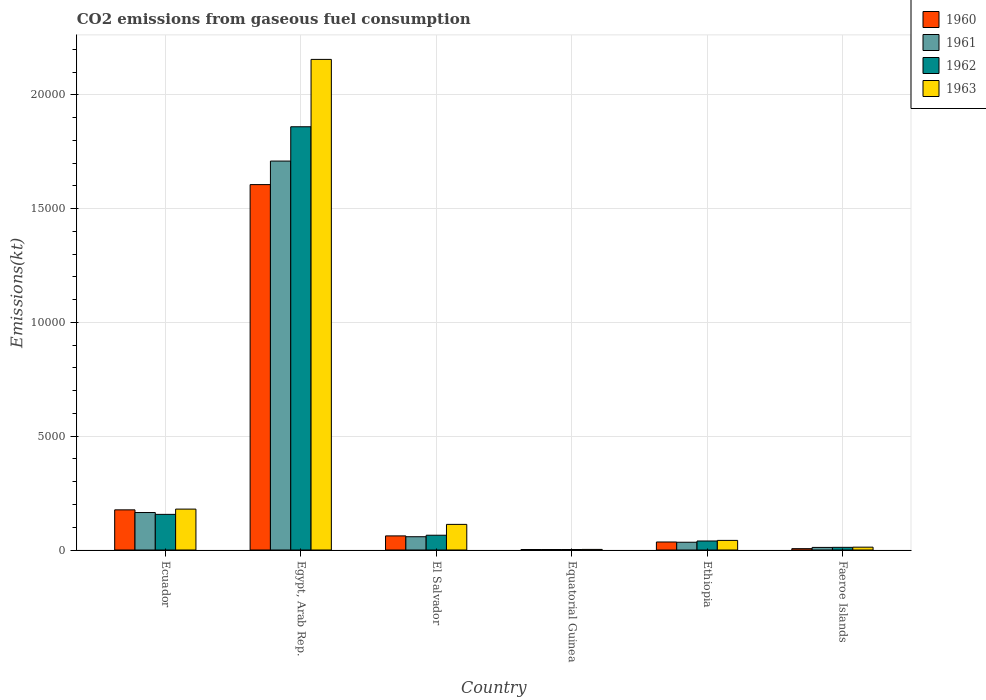How many groups of bars are there?
Your response must be concise. 6. How many bars are there on the 4th tick from the left?
Your answer should be very brief. 4. What is the label of the 4th group of bars from the left?
Make the answer very short. Equatorial Guinea. In how many cases, is the number of bars for a given country not equal to the number of legend labels?
Your answer should be very brief. 0. What is the amount of CO2 emitted in 1960 in Equatorial Guinea?
Ensure brevity in your answer.  22. Across all countries, what is the maximum amount of CO2 emitted in 1960?
Your response must be concise. 1.61e+04. Across all countries, what is the minimum amount of CO2 emitted in 1960?
Offer a very short reply. 22. In which country was the amount of CO2 emitted in 1962 maximum?
Give a very brief answer. Egypt, Arab Rep. In which country was the amount of CO2 emitted in 1963 minimum?
Keep it short and to the point. Equatorial Guinea. What is the total amount of CO2 emitted in 1961 in the graph?
Give a very brief answer. 1.98e+04. What is the difference between the amount of CO2 emitted in 1960 in Ecuador and that in Faeroe Islands?
Your response must be concise. 1705.15. What is the difference between the amount of CO2 emitted in 1962 in Equatorial Guinea and the amount of CO2 emitted in 1963 in Ecuador?
Your answer should be compact. -1774.83. What is the average amount of CO2 emitted in 1962 per country?
Your answer should be very brief. 3557.6. What is the difference between the amount of CO2 emitted of/in 1962 and amount of CO2 emitted of/in 1963 in Ecuador?
Your response must be concise. -231.02. What is the ratio of the amount of CO2 emitted in 1962 in El Salvador to that in Faeroe Islands?
Provide a succinct answer. 5.53. Is the difference between the amount of CO2 emitted in 1962 in Ecuador and El Salvador greater than the difference between the amount of CO2 emitted in 1963 in Ecuador and El Salvador?
Provide a succinct answer. Yes. What is the difference between the highest and the second highest amount of CO2 emitted in 1962?
Provide a short and direct response. -1.79e+04. What is the difference between the highest and the lowest amount of CO2 emitted in 1961?
Give a very brief answer. 1.71e+04. In how many countries, is the amount of CO2 emitted in 1963 greater than the average amount of CO2 emitted in 1963 taken over all countries?
Provide a succinct answer. 1. What does the 1st bar from the right in Faeroe Islands represents?
Your response must be concise. 1963. How many bars are there?
Your answer should be compact. 24. Are all the bars in the graph horizontal?
Your answer should be compact. No. How many countries are there in the graph?
Provide a short and direct response. 6. Are the values on the major ticks of Y-axis written in scientific E-notation?
Ensure brevity in your answer.  No. Does the graph contain any zero values?
Give a very brief answer. No. Where does the legend appear in the graph?
Keep it short and to the point. Top right. How many legend labels are there?
Provide a succinct answer. 4. How are the legend labels stacked?
Your answer should be compact. Vertical. What is the title of the graph?
Your response must be concise. CO2 emissions from gaseous fuel consumption. What is the label or title of the X-axis?
Offer a terse response. Country. What is the label or title of the Y-axis?
Your response must be concise. Emissions(kt). What is the Emissions(kt) in 1960 in Ecuador?
Your answer should be very brief. 1763.83. What is the Emissions(kt) in 1961 in Ecuador?
Give a very brief answer. 1646.48. What is the Emissions(kt) in 1962 in Ecuador?
Your answer should be compact. 1565.81. What is the Emissions(kt) of 1963 in Ecuador?
Offer a very short reply. 1796.83. What is the Emissions(kt) in 1960 in Egypt, Arab Rep.?
Your response must be concise. 1.61e+04. What is the Emissions(kt) of 1961 in Egypt, Arab Rep.?
Your answer should be very brief. 1.71e+04. What is the Emissions(kt) of 1962 in Egypt, Arab Rep.?
Offer a terse response. 1.86e+04. What is the Emissions(kt) in 1963 in Egypt, Arab Rep.?
Your answer should be very brief. 2.16e+04. What is the Emissions(kt) in 1960 in El Salvador?
Your answer should be compact. 619.72. What is the Emissions(kt) of 1961 in El Salvador?
Provide a succinct answer. 583.05. What is the Emissions(kt) in 1962 in El Salvador?
Give a very brief answer. 649.06. What is the Emissions(kt) of 1963 in El Salvador?
Your response must be concise. 1125.77. What is the Emissions(kt) in 1960 in Equatorial Guinea?
Give a very brief answer. 22. What is the Emissions(kt) of 1961 in Equatorial Guinea?
Provide a short and direct response. 22. What is the Emissions(kt) in 1962 in Equatorial Guinea?
Give a very brief answer. 22. What is the Emissions(kt) in 1963 in Equatorial Guinea?
Give a very brief answer. 25.67. What is the Emissions(kt) in 1960 in Ethiopia?
Keep it short and to the point. 352.03. What is the Emissions(kt) in 1961 in Ethiopia?
Offer a terse response. 341.03. What is the Emissions(kt) in 1962 in Ethiopia?
Your answer should be very brief. 396.04. What is the Emissions(kt) in 1963 in Ethiopia?
Offer a terse response. 421.7. What is the Emissions(kt) in 1960 in Faeroe Islands?
Give a very brief answer. 58.67. What is the Emissions(kt) of 1961 in Faeroe Islands?
Give a very brief answer. 113.68. What is the Emissions(kt) in 1962 in Faeroe Islands?
Ensure brevity in your answer.  117.34. What is the Emissions(kt) of 1963 in Faeroe Islands?
Your answer should be very brief. 124.68. Across all countries, what is the maximum Emissions(kt) of 1960?
Provide a short and direct response. 1.61e+04. Across all countries, what is the maximum Emissions(kt) in 1961?
Your answer should be compact. 1.71e+04. Across all countries, what is the maximum Emissions(kt) in 1962?
Provide a succinct answer. 1.86e+04. Across all countries, what is the maximum Emissions(kt) in 1963?
Your answer should be very brief. 2.16e+04. Across all countries, what is the minimum Emissions(kt) of 1960?
Ensure brevity in your answer.  22. Across all countries, what is the minimum Emissions(kt) of 1961?
Ensure brevity in your answer.  22. Across all countries, what is the minimum Emissions(kt) of 1962?
Your answer should be compact. 22. Across all countries, what is the minimum Emissions(kt) of 1963?
Your answer should be very brief. 25.67. What is the total Emissions(kt) in 1960 in the graph?
Your answer should be very brief. 1.89e+04. What is the total Emissions(kt) in 1961 in the graph?
Make the answer very short. 1.98e+04. What is the total Emissions(kt) of 1962 in the graph?
Provide a succinct answer. 2.13e+04. What is the total Emissions(kt) in 1963 in the graph?
Your answer should be compact. 2.50e+04. What is the difference between the Emissions(kt) in 1960 in Ecuador and that in Egypt, Arab Rep.?
Your response must be concise. -1.43e+04. What is the difference between the Emissions(kt) in 1961 in Ecuador and that in Egypt, Arab Rep.?
Your answer should be compact. -1.54e+04. What is the difference between the Emissions(kt) of 1962 in Ecuador and that in Egypt, Arab Rep.?
Ensure brevity in your answer.  -1.70e+04. What is the difference between the Emissions(kt) of 1963 in Ecuador and that in Egypt, Arab Rep.?
Offer a very short reply. -1.98e+04. What is the difference between the Emissions(kt) in 1960 in Ecuador and that in El Salvador?
Offer a very short reply. 1144.1. What is the difference between the Emissions(kt) in 1961 in Ecuador and that in El Salvador?
Ensure brevity in your answer.  1063.43. What is the difference between the Emissions(kt) in 1962 in Ecuador and that in El Salvador?
Provide a succinct answer. 916.75. What is the difference between the Emissions(kt) in 1963 in Ecuador and that in El Salvador?
Keep it short and to the point. 671.06. What is the difference between the Emissions(kt) in 1960 in Ecuador and that in Equatorial Guinea?
Give a very brief answer. 1741.83. What is the difference between the Emissions(kt) in 1961 in Ecuador and that in Equatorial Guinea?
Your response must be concise. 1624.48. What is the difference between the Emissions(kt) of 1962 in Ecuador and that in Equatorial Guinea?
Give a very brief answer. 1543.81. What is the difference between the Emissions(kt) of 1963 in Ecuador and that in Equatorial Guinea?
Ensure brevity in your answer.  1771.16. What is the difference between the Emissions(kt) in 1960 in Ecuador and that in Ethiopia?
Provide a short and direct response. 1411.8. What is the difference between the Emissions(kt) of 1961 in Ecuador and that in Ethiopia?
Your answer should be very brief. 1305.45. What is the difference between the Emissions(kt) of 1962 in Ecuador and that in Ethiopia?
Give a very brief answer. 1169.77. What is the difference between the Emissions(kt) of 1963 in Ecuador and that in Ethiopia?
Give a very brief answer. 1375.12. What is the difference between the Emissions(kt) in 1960 in Ecuador and that in Faeroe Islands?
Your response must be concise. 1705.15. What is the difference between the Emissions(kt) in 1961 in Ecuador and that in Faeroe Islands?
Provide a short and direct response. 1532.81. What is the difference between the Emissions(kt) in 1962 in Ecuador and that in Faeroe Islands?
Provide a short and direct response. 1448.46. What is the difference between the Emissions(kt) of 1963 in Ecuador and that in Faeroe Islands?
Offer a very short reply. 1672.15. What is the difference between the Emissions(kt) in 1960 in Egypt, Arab Rep. and that in El Salvador?
Your response must be concise. 1.54e+04. What is the difference between the Emissions(kt) of 1961 in Egypt, Arab Rep. and that in El Salvador?
Your response must be concise. 1.65e+04. What is the difference between the Emissions(kt) in 1962 in Egypt, Arab Rep. and that in El Salvador?
Keep it short and to the point. 1.79e+04. What is the difference between the Emissions(kt) in 1963 in Egypt, Arab Rep. and that in El Salvador?
Your answer should be compact. 2.04e+04. What is the difference between the Emissions(kt) of 1960 in Egypt, Arab Rep. and that in Equatorial Guinea?
Provide a succinct answer. 1.60e+04. What is the difference between the Emissions(kt) in 1961 in Egypt, Arab Rep. and that in Equatorial Guinea?
Provide a short and direct response. 1.71e+04. What is the difference between the Emissions(kt) in 1962 in Egypt, Arab Rep. and that in Equatorial Guinea?
Provide a short and direct response. 1.86e+04. What is the difference between the Emissions(kt) in 1963 in Egypt, Arab Rep. and that in Equatorial Guinea?
Provide a short and direct response. 2.15e+04. What is the difference between the Emissions(kt) of 1960 in Egypt, Arab Rep. and that in Ethiopia?
Give a very brief answer. 1.57e+04. What is the difference between the Emissions(kt) of 1961 in Egypt, Arab Rep. and that in Ethiopia?
Offer a terse response. 1.67e+04. What is the difference between the Emissions(kt) of 1962 in Egypt, Arab Rep. and that in Ethiopia?
Make the answer very short. 1.82e+04. What is the difference between the Emissions(kt) in 1963 in Egypt, Arab Rep. and that in Ethiopia?
Make the answer very short. 2.11e+04. What is the difference between the Emissions(kt) in 1960 in Egypt, Arab Rep. and that in Faeroe Islands?
Ensure brevity in your answer.  1.60e+04. What is the difference between the Emissions(kt) of 1961 in Egypt, Arab Rep. and that in Faeroe Islands?
Your response must be concise. 1.70e+04. What is the difference between the Emissions(kt) of 1962 in Egypt, Arab Rep. and that in Faeroe Islands?
Keep it short and to the point. 1.85e+04. What is the difference between the Emissions(kt) of 1963 in Egypt, Arab Rep. and that in Faeroe Islands?
Keep it short and to the point. 2.14e+04. What is the difference between the Emissions(kt) of 1960 in El Salvador and that in Equatorial Guinea?
Provide a short and direct response. 597.72. What is the difference between the Emissions(kt) in 1961 in El Salvador and that in Equatorial Guinea?
Make the answer very short. 561.05. What is the difference between the Emissions(kt) of 1962 in El Salvador and that in Equatorial Guinea?
Ensure brevity in your answer.  627.06. What is the difference between the Emissions(kt) in 1963 in El Salvador and that in Equatorial Guinea?
Your answer should be compact. 1100.1. What is the difference between the Emissions(kt) of 1960 in El Salvador and that in Ethiopia?
Make the answer very short. 267.69. What is the difference between the Emissions(kt) in 1961 in El Salvador and that in Ethiopia?
Offer a very short reply. 242.02. What is the difference between the Emissions(kt) in 1962 in El Salvador and that in Ethiopia?
Your answer should be compact. 253.02. What is the difference between the Emissions(kt) of 1963 in El Salvador and that in Ethiopia?
Provide a short and direct response. 704.06. What is the difference between the Emissions(kt) of 1960 in El Salvador and that in Faeroe Islands?
Make the answer very short. 561.05. What is the difference between the Emissions(kt) in 1961 in El Salvador and that in Faeroe Islands?
Ensure brevity in your answer.  469.38. What is the difference between the Emissions(kt) of 1962 in El Salvador and that in Faeroe Islands?
Your response must be concise. 531.72. What is the difference between the Emissions(kt) in 1963 in El Salvador and that in Faeroe Islands?
Make the answer very short. 1001.09. What is the difference between the Emissions(kt) of 1960 in Equatorial Guinea and that in Ethiopia?
Offer a very short reply. -330.03. What is the difference between the Emissions(kt) in 1961 in Equatorial Guinea and that in Ethiopia?
Make the answer very short. -319.03. What is the difference between the Emissions(kt) in 1962 in Equatorial Guinea and that in Ethiopia?
Provide a succinct answer. -374.03. What is the difference between the Emissions(kt) of 1963 in Equatorial Guinea and that in Ethiopia?
Offer a very short reply. -396.04. What is the difference between the Emissions(kt) in 1960 in Equatorial Guinea and that in Faeroe Islands?
Your answer should be very brief. -36.67. What is the difference between the Emissions(kt) of 1961 in Equatorial Guinea and that in Faeroe Islands?
Offer a very short reply. -91.67. What is the difference between the Emissions(kt) in 1962 in Equatorial Guinea and that in Faeroe Islands?
Your answer should be compact. -95.34. What is the difference between the Emissions(kt) of 1963 in Equatorial Guinea and that in Faeroe Islands?
Your response must be concise. -99.01. What is the difference between the Emissions(kt) of 1960 in Ethiopia and that in Faeroe Islands?
Your response must be concise. 293.36. What is the difference between the Emissions(kt) of 1961 in Ethiopia and that in Faeroe Islands?
Offer a very short reply. 227.35. What is the difference between the Emissions(kt) in 1962 in Ethiopia and that in Faeroe Islands?
Offer a terse response. 278.69. What is the difference between the Emissions(kt) in 1963 in Ethiopia and that in Faeroe Islands?
Your answer should be compact. 297.03. What is the difference between the Emissions(kt) in 1960 in Ecuador and the Emissions(kt) in 1961 in Egypt, Arab Rep.?
Give a very brief answer. -1.53e+04. What is the difference between the Emissions(kt) of 1960 in Ecuador and the Emissions(kt) of 1962 in Egypt, Arab Rep.?
Provide a succinct answer. -1.68e+04. What is the difference between the Emissions(kt) in 1960 in Ecuador and the Emissions(kt) in 1963 in Egypt, Arab Rep.?
Offer a very short reply. -1.98e+04. What is the difference between the Emissions(kt) in 1961 in Ecuador and the Emissions(kt) in 1962 in Egypt, Arab Rep.?
Ensure brevity in your answer.  -1.69e+04. What is the difference between the Emissions(kt) of 1961 in Ecuador and the Emissions(kt) of 1963 in Egypt, Arab Rep.?
Ensure brevity in your answer.  -1.99e+04. What is the difference between the Emissions(kt) of 1962 in Ecuador and the Emissions(kt) of 1963 in Egypt, Arab Rep.?
Offer a very short reply. -2.00e+04. What is the difference between the Emissions(kt) in 1960 in Ecuador and the Emissions(kt) in 1961 in El Salvador?
Make the answer very short. 1180.77. What is the difference between the Emissions(kt) of 1960 in Ecuador and the Emissions(kt) of 1962 in El Salvador?
Provide a succinct answer. 1114.77. What is the difference between the Emissions(kt) of 1960 in Ecuador and the Emissions(kt) of 1963 in El Salvador?
Your answer should be compact. 638.06. What is the difference between the Emissions(kt) of 1961 in Ecuador and the Emissions(kt) of 1962 in El Salvador?
Offer a very short reply. 997.42. What is the difference between the Emissions(kt) of 1961 in Ecuador and the Emissions(kt) of 1963 in El Salvador?
Provide a succinct answer. 520.71. What is the difference between the Emissions(kt) in 1962 in Ecuador and the Emissions(kt) in 1963 in El Salvador?
Offer a terse response. 440.04. What is the difference between the Emissions(kt) in 1960 in Ecuador and the Emissions(kt) in 1961 in Equatorial Guinea?
Provide a succinct answer. 1741.83. What is the difference between the Emissions(kt) in 1960 in Ecuador and the Emissions(kt) in 1962 in Equatorial Guinea?
Ensure brevity in your answer.  1741.83. What is the difference between the Emissions(kt) in 1960 in Ecuador and the Emissions(kt) in 1963 in Equatorial Guinea?
Keep it short and to the point. 1738.16. What is the difference between the Emissions(kt) of 1961 in Ecuador and the Emissions(kt) of 1962 in Equatorial Guinea?
Offer a very short reply. 1624.48. What is the difference between the Emissions(kt) in 1961 in Ecuador and the Emissions(kt) in 1963 in Equatorial Guinea?
Your answer should be very brief. 1620.81. What is the difference between the Emissions(kt) in 1962 in Ecuador and the Emissions(kt) in 1963 in Equatorial Guinea?
Offer a very short reply. 1540.14. What is the difference between the Emissions(kt) of 1960 in Ecuador and the Emissions(kt) of 1961 in Ethiopia?
Your answer should be very brief. 1422.8. What is the difference between the Emissions(kt) in 1960 in Ecuador and the Emissions(kt) in 1962 in Ethiopia?
Ensure brevity in your answer.  1367.79. What is the difference between the Emissions(kt) in 1960 in Ecuador and the Emissions(kt) in 1963 in Ethiopia?
Offer a very short reply. 1342.12. What is the difference between the Emissions(kt) of 1961 in Ecuador and the Emissions(kt) of 1962 in Ethiopia?
Ensure brevity in your answer.  1250.45. What is the difference between the Emissions(kt) of 1961 in Ecuador and the Emissions(kt) of 1963 in Ethiopia?
Offer a very short reply. 1224.78. What is the difference between the Emissions(kt) of 1962 in Ecuador and the Emissions(kt) of 1963 in Ethiopia?
Offer a terse response. 1144.1. What is the difference between the Emissions(kt) of 1960 in Ecuador and the Emissions(kt) of 1961 in Faeroe Islands?
Give a very brief answer. 1650.15. What is the difference between the Emissions(kt) in 1960 in Ecuador and the Emissions(kt) in 1962 in Faeroe Islands?
Provide a succinct answer. 1646.48. What is the difference between the Emissions(kt) of 1960 in Ecuador and the Emissions(kt) of 1963 in Faeroe Islands?
Provide a succinct answer. 1639.15. What is the difference between the Emissions(kt) in 1961 in Ecuador and the Emissions(kt) in 1962 in Faeroe Islands?
Your response must be concise. 1529.14. What is the difference between the Emissions(kt) of 1961 in Ecuador and the Emissions(kt) of 1963 in Faeroe Islands?
Make the answer very short. 1521.81. What is the difference between the Emissions(kt) in 1962 in Ecuador and the Emissions(kt) in 1963 in Faeroe Islands?
Your answer should be very brief. 1441.13. What is the difference between the Emissions(kt) in 1960 in Egypt, Arab Rep. and the Emissions(kt) in 1961 in El Salvador?
Provide a short and direct response. 1.55e+04. What is the difference between the Emissions(kt) of 1960 in Egypt, Arab Rep. and the Emissions(kt) of 1962 in El Salvador?
Provide a short and direct response. 1.54e+04. What is the difference between the Emissions(kt) of 1960 in Egypt, Arab Rep. and the Emissions(kt) of 1963 in El Salvador?
Your response must be concise. 1.49e+04. What is the difference between the Emissions(kt) of 1961 in Egypt, Arab Rep. and the Emissions(kt) of 1962 in El Salvador?
Ensure brevity in your answer.  1.64e+04. What is the difference between the Emissions(kt) in 1961 in Egypt, Arab Rep. and the Emissions(kt) in 1963 in El Salvador?
Offer a very short reply. 1.60e+04. What is the difference between the Emissions(kt) in 1962 in Egypt, Arab Rep. and the Emissions(kt) in 1963 in El Salvador?
Give a very brief answer. 1.75e+04. What is the difference between the Emissions(kt) in 1960 in Egypt, Arab Rep. and the Emissions(kt) in 1961 in Equatorial Guinea?
Offer a very short reply. 1.60e+04. What is the difference between the Emissions(kt) of 1960 in Egypt, Arab Rep. and the Emissions(kt) of 1962 in Equatorial Guinea?
Ensure brevity in your answer.  1.60e+04. What is the difference between the Emissions(kt) of 1960 in Egypt, Arab Rep. and the Emissions(kt) of 1963 in Equatorial Guinea?
Give a very brief answer. 1.60e+04. What is the difference between the Emissions(kt) of 1961 in Egypt, Arab Rep. and the Emissions(kt) of 1962 in Equatorial Guinea?
Give a very brief answer. 1.71e+04. What is the difference between the Emissions(kt) of 1961 in Egypt, Arab Rep. and the Emissions(kt) of 1963 in Equatorial Guinea?
Make the answer very short. 1.71e+04. What is the difference between the Emissions(kt) in 1962 in Egypt, Arab Rep. and the Emissions(kt) in 1963 in Equatorial Guinea?
Provide a short and direct response. 1.86e+04. What is the difference between the Emissions(kt) in 1960 in Egypt, Arab Rep. and the Emissions(kt) in 1961 in Ethiopia?
Ensure brevity in your answer.  1.57e+04. What is the difference between the Emissions(kt) of 1960 in Egypt, Arab Rep. and the Emissions(kt) of 1962 in Ethiopia?
Your answer should be compact. 1.57e+04. What is the difference between the Emissions(kt) in 1960 in Egypt, Arab Rep. and the Emissions(kt) in 1963 in Ethiopia?
Provide a short and direct response. 1.56e+04. What is the difference between the Emissions(kt) of 1961 in Egypt, Arab Rep. and the Emissions(kt) of 1962 in Ethiopia?
Make the answer very short. 1.67e+04. What is the difference between the Emissions(kt) of 1961 in Egypt, Arab Rep. and the Emissions(kt) of 1963 in Ethiopia?
Provide a short and direct response. 1.67e+04. What is the difference between the Emissions(kt) in 1962 in Egypt, Arab Rep. and the Emissions(kt) in 1963 in Ethiopia?
Keep it short and to the point. 1.82e+04. What is the difference between the Emissions(kt) of 1960 in Egypt, Arab Rep. and the Emissions(kt) of 1961 in Faeroe Islands?
Provide a short and direct response. 1.59e+04. What is the difference between the Emissions(kt) in 1960 in Egypt, Arab Rep. and the Emissions(kt) in 1962 in Faeroe Islands?
Your answer should be compact. 1.59e+04. What is the difference between the Emissions(kt) in 1960 in Egypt, Arab Rep. and the Emissions(kt) in 1963 in Faeroe Islands?
Your answer should be compact. 1.59e+04. What is the difference between the Emissions(kt) in 1961 in Egypt, Arab Rep. and the Emissions(kt) in 1962 in Faeroe Islands?
Provide a short and direct response. 1.70e+04. What is the difference between the Emissions(kt) of 1961 in Egypt, Arab Rep. and the Emissions(kt) of 1963 in Faeroe Islands?
Ensure brevity in your answer.  1.70e+04. What is the difference between the Emissions(kt) of 1962 in Egypt, Arab Rep. and the Emissions(kt) of 1963 in Faeroe Islands?
Provide a succinct answer. 1.85e+04. What is the difference between the Emissions(kt) of 1960 in El Salvador and the Emissions(kt) of 1961 in Equatorial Guinea?
Your answer should be very brief. 597.72. What is the difference between the Emissions(kt) of 1960 in El Salvador and the Emissions(kt) of 1962 in Equatorial Guinea?
Offer a very short reply. 597.72. What is the difference between the Emissions(kt) of 1960 in El Salvador and the Emissions(kt) of 1963 in Equatorial Guinea?
Offer a terse response. 594.05. What is the difference between the Emissions(kt) in 1961 in El Salvador and the Emissions(kt) in 1962 in Equatorial Guinea?
Keep it short and to the point. 561.05. What is the difference between the Emissions(kt) in 1961 in El Salvador and the Emissions(kt) in 1963 in Equatorial Guinea?
Give a very brief answer. 557.38. What is the difference between the Emissions(kt) of 1962 in El Salvador and the Emissions(kt) of 1963 in Equatorial Guinea?
Offer a terse response. 623.39. What is the difference between the Emissions(kt) of 1960 in El Salvador and the Emissions(kt) of 1961 in Ethiopia?
Your answer should be compact. 278.69. What is the difference between the Emissions(kt) of 1960 in El Salvador and the Emissions(kt) of 1962 in Ethiopia?
Make the answer very short. 223.69. What is the difference between the Emissions(kt) in 1960 in El Salvador and the Emissions(kt) in 1963 in Ethiopia?
Offer a very short reply. 198.02. What is the difference between the Emissions(kt) in 1961 in El Salvador and the Emissions(kt) in 1962 in Ethiopia?
Your answer should be very brief. 187.02. What is the difference between the Emissions(kt) in 1961 in El Salvador and the Emissions(kt) in 1963 in Ethiopia?
Offer a terse response. 161.35. What is the difference between the Emissions(kt) of 1962 in El Salvador and the Emissions(kt) of 1963 in Ethiopia?
Your response must be concise. 227.35. What is the difference between the Emissions(kt) in 1960 in El Salvador and the Emissions(kt) in 1961 in Faeroe Islands?
Your answer should be compact. 506.05. What is the difference between the Emissions(kt) in 1960 in El Salvador and the Emissions(kt) in 1962 in Faeroe Islands?
Provide a short and direct response. 502.38. What is the difference between the Emissions(kt) of 1960 in El Salvador and the Emissions(kt) of 1963 in Faeroe Islands?
Offer a terse response. 495.05. What is the difference between the Emissions(kt) of 1961 in El Salvador and the Emissions(kt) of 1962 in Faeroe Islands?
Make the answer very short. 465.71. What is the difference between the Emissions(kt) in 1961 in El Salvador and the Emissions(kt) in 1963 in Faeroe Islands?
Give a very brief answer. 458.38. What is the difference between the Emissions(kt) of 1962 in El Salvador and the Emissions(kt) of 1963 in Faeroe Islands?
Keep it short and to the point. 524.38. What is the difference between the Emissions(kt) of 1960 in Equatorial Guinea and the Emissions(kt) of 1961 in Ethiopia?
Offer a terse response. -319.03. What is the difference between the Emissions(kt) of 1960 in Equatorial Guinea and the Emissions(kt) of 1962 in Ethiopia?
Provide a succinct answer. -374.03. What is the difference between the Emissions(kt) in 1960 in Equatorial Guinea and the Emissions(kt) in 1963 in Ethiopia?
Provide a succinct answer. -399.7. What is the difference between the Emissions(kt) of 1961 in Equatorial Guinea and the Emissions(kt) of 1962 in Ethiopia?
Keep it short and to the point. -374.03. What is the difference between the Emissions(kt) in 1961 in Equatorial Guinea and the Emissions(kt) in 1963 in Ethiopia?
Keep it short and to the point. -399.7. What is the difference between the Emissions(kt) of 1962 in Equatorial Guinea and the Emissions(kt) of 1963 in Ethiopia?
Your answer should be compact. -399.7. What is the difference between the Emissions(kt) of 1960 in Equatorial Guinea and the Emissions(kt) of 1961 in Faeroe Islands?
Provide a succinct answer. -91.67. What is the difference between the Emissions(kt) of 1960 in Equatorial Guinea and the Emissions(kt) of 1962 in Faeroe Islands?
Keep it short and to the point. -95.34. What is the difference between the Emissions(kt) in 1960 in Equatorial Guinea and the Emissions(kt) in 1963 in Faeroe Islands?
Your response must be concise. -102.68. What is the difference between the Emissions(kt) of 1961 in Equatorial Guinea and the Emissions(kt) of 1962 in Faeroe Islands?
Ensure brevity in your answer.  -95.34. What is the difference between the Emissions(kt) in 1961 in Equatorial Guinea and the Emissions(kt) in 1963 in Faeroe Islands?
Your answer should be very brief. -102.68. What is the difference between the Emissions(kt) of 1962 in Equatorial Guinea and the Emissions(kt) of 1963 in Faeroe Islands?
Your answer should be very brief. -102.68. What is the difference between the Emissions(kt) in 1960 in Ethiopia and the Emissions(kt) in 1961 in Faeroe Islands?
Provide a succinct answer. 238.35. What is the difference between the Emissions(kt) in 1960 in Ethiopia and the Emissions(kt) in 1962 in Faeroe Islands?
Offer a very short reply. 234.69. What is the difference between the Emissions(kt) in 1960 in Ethiopia and the Emissions(kt) in 1963 in Faeroe Islands?
Your response must be concise. 227.35. What is the difference between the Emissions(kt) of 1961 in Ethiopia and the Emissions(kt) of 1962 in Faeroe Islands?
Offer a very short reply. 223.69. What is the difference between the Emissions(kt) in 1961 in Ethiopia and the Emissions(kt) in 1963 in Faeroe Islands?
Provide a succinct answer. 216.35. What is the difference between the Emissions(kt) of 1962 in Ethiopia and the Emissions(kt) of 1963 in Faeroe Islands?
Keep it short and to the point. 271.36. What is the average Emissions(kt) of 1960 per country?
Keep it short and to the point. 3145.06. What is the average Emissions(kt) in 1961 per country?
Offer a very short reply. 3299.08. What is the average Emissions(kt) of 1962 per country?
Offer a terse response. 3557.6. What is the average Emissions(kt) in 1963 per country?
Offer a terse response. 4174.88. What is the difference between the Emissions(kt) of 1960 and Emissions(kt) of 1961 in Ecuador?
Your answer should be very brief. 117.34. What is the difference between the Emissions(kt) of 1960 and Emissions(kt) of 1962 in Ecuador?
Make the answer very short. 198.02. What is the difference between the Emissions(kt) in 1960 and Emissions(kt) in 1963 in Ecuador?
Provide a succinct answer. -33. What is the difference between the Emissions(kt) in 1961 and Emissions(kt) in 1962 in Ecuador?
Provide a short and direct response. 80.67. What is the difference between the Emissions(kt) of 1961 and Emissions(kt) of 1963 in Ecuador?
Your answer should be compact. -150.35. What is the difference between the Emissions(kt) in 1962 and Emissions(kt) in 1963 in Ecuador?
Ensure brevity in your answer.  -231.02. What is the difference between the Emissions(kt) in 1960 and Emissions(kt) in 1961 in Egypt, Arab Rep.?
Ensure brevity in your answer.  -1034.09. What is the difference between the Emissions(kt) of 1960 and Emissions(kt) of 1962 in Egypt, Arab Rep.?
Your answer should be very brief. -2541.23. What is the difference between the Emissions(kt) of 1960 and Emissions(kt) of 1963 in Egypt, Arab Rep.?
Offer a terse response. -5500.5. What is the difference between the Emissions(kt) in 1961 and Emissions(kt) in 1962 in Egypt, Arab Rep.?
Provide a short and direct response. -1507.14. What is the difference between the Emissions(kt) in 1961 and Emissions(kt) in 1963 in Egypt, Arab Rep.?
Your answer should be very brief. -4466.41. What is the difference between the Emissions(kt) of 1962 and Emissions(kt) of 1963 in Egypt, Arab Rep.?
Offer a very short reply. -2959.27. What is the difference between the Emissions(kt) in 1960 and Emissions(kt) in 1961 in El Salvador?
Make the answer very short. 36.67. What is the difference between the Emissions(kt) of 1960 and Emissions(kt) of 1962 in El Salvador?
Keep it short and to the point. -29.34. What is the difference between the Emissions(kt) in 1960 and Emissions(kt) in 1963 in El Salvador?
Provide a short and direct response. -506.05. What is the difference between the Emissions(kt) of 1961 and Emissions(kt) of 1962 in El Salvador?
Make the answer very short. -66.01. What is the difference between the Emissions(kt) in 1961 and Emissions(kt) in 1963 in El Salvador?
Provide a succinct answer. -542.72. What is the difference between the Emissions(kt) in 1962 and Emissions(kt) in 1963 in El Salvador?
Ensure brevity in your answer.  -476.71. What is the difference between the Emissions(kt) of 1960 and Emissions(kt) of 1961 in Equatorial Guinea?
Provide a succinct answer. 0. What is the difference between the Emissions(kt) of 1960 and Emissions(kt) of 1963 in Equatorial Guinea?
Ensure brevity in your answer.  -3.67. What is the difference between the Emissions(kt) of 1961 and Emissions(kt) of 1962 in Equatorial Guinea?
Ensure brevity in your answer.  0. What is the difference between the Emissions(kt) in 1961 and Emissions(kt) in 1963 in Equatorial Guinea?
Provide a succinct answer. -3.67. What is the difference between the Emissions(kt) of 1962 and Emissions(kt) of 1963 in Equatorial Guinea?
Give a very brief answer. -3.67. What is the difference between the Emissions(kt) in 1960 and Emissions(kt) in 1961 in Ethiopia?
Offer a terse response. 11. What is the difference between the Emissions(kt) in 1960 and Emissions(kt) in 1962 in Ethiopia?
Your answer should be very brief. -44. What is the difference between the Emissions(kt) of 1960 and Emissions(kt) of 1963 in Ethiopia?
Your answer should be compact. -69.67. What is the difference between the Emissions(kt) of 1961 and Emissions(kt) of 1962 in Ethiopia?
Your answer should be very brief. -55.01. What is the difference between the Emissions(kt) of 1961 and Emissions(kt) of 1963 in Ethiopia?
Provide a short and direct response. -80.67. What is the difference between the Emissions(kt) of 1962 and Emissions(kt) of 1963 in Ethiopia?
Make the answer very short. -25.67. What is the difference between the Emissions(kt) of 1960 and Emissions(kt) of 1961 in Faeroe Islands?
Your answer should be compact. -55.01. What is the difference between the Emissions(kt) in 1960 and Emissions(kt) in 1962 in Faeroe Islands?
Offer a very short reply. -58.67. What is the difference between the Emissions(kt) in 1960 and Emissions(kt) in 1963 in Faeroe Islands?
Give a very brief answer. -66.01. What is the difference between the Emissions(kt) in 1961 and Emissions(kt) in 1962 in Faeroe Islands?
Keep it short and to the point. -3.67. What is the difference between the Emissions(kt) in 1961 and Emissions(kt) in 1963 in Faeroe Islands?
Your answer should be very brief. -11. What is the difference between the Emissions(kt) of 1962 and Emissions(kt) of 1963 in Faeroe Islands?
Keep it short and to the point. -7.33. What is the ratio of the Emissions(kt) in 1960 in Ecuador to that in Egypt, Arab Rep.?
Provide a succinct answer. 0.11. What is the ratio of the Emissions(kt) in 1961 in Ecuador to that in Egypt, Arab Rep.?
Your answer should be compact. 0.1. What is the ratio of the Emissions(kt) in 1962 in Ecuador to that in Egypt, Arab Rep.?
Make the answer very short. 0.08. What is the ratio of the Emissions(kt) in 1963 in Ecuador to that in Egypt, Arab Rep.?
Offer a very short reply. 0.08. What is the ratio of the Emissions(kt) in 1960 in Ecuador to that in El Salvador?
Offer a terse response. 2.85. What is the ratio of the Emissions(kt) in 1961 in Ecuador to that in El Salvador?
Provide a succinct answer. 2.82. What is the ratio of the Emissions(kt) in 1962 in Ecuador to that in El Salvador?
Keep it short and to the point. 2.41. What is the ratio of the Emissions(kt) of 1963 in Ecuador to that in El Salvador?
Your answer should be compact. 1.6. What is the ratio of the Emissions(kt) in 1960 in Ecuador to that in Equatorial Guinea?
Keep it short and to the point. 80.17. What is the ratio of the Emissions(kt) of 1961 in Ecuador to that in Equatorial Guinea?
Keep it short and to the point. 74.83. What is the ratio of the Emissions(kt) of 1962 in Ecuador to that in Equatorial Guinea?
Provide a succinct answer. 71.17. What is the ratio of the Emissions(kt) in 1960 in Ecuador to that in Ethiopia?
Your response must be concise. 5.01. What is the ratio of the Emissions(kt) in 1961 in Ecuador to that in Ethiopia?
Provide a short and direct response. 4.83. What is the ratio of the Emissions(kt) of 1962 in Ecuador to that in Ethiopia?
Your answer should be very brief. 3.95. What is the ratio of the Emissions(kt) in 1963 in Ecuador to that in Ethiopia?
Offer a terse response. 4.26. What is the ratio of the Emissions(kt) in 1960 in Ecuador to that in Faeroe Islands?
Your response must be concise. 30.06. What is the ratio of the Emissions(kt) in 1961 in Ecuador to that in Faeroe Islands?
Ensure brevity in your answer.  14.48. What is the ratio of the Emissions(kt) of 1962 in Ecuador to that in Faeroe Islands?
Ensure brevity in your answer.  13.34. What is the ratio of the Emissions(kt) of 1963 in Ecuador to that in Faeroe Islands?
Offer a very short reply. 14.41. What is the ratio of the Emissions(kt) of 1960 in Egypt, Arab Rep. to that in El Salvador?
Provide a succinct answer. 25.91. What is the ratio of the Emissions(kt) of 1961 in Egypt, Arab Rep. to that in El Salvador?
Provide a short and direct response. 29.31. What is the ratio of the Emissions(kt) of 1962 in Egypt, Arab Rep. to that in El Salvador?
Give a very brief answer. 28.65. What is the ratio of the Emissions(kt) of 1963 in Egypt, Arab Rep. to that in El Salvador?
Provide a short and direct response. 19.15. What is the ratio of the Emissions(kt) of 1960 in Egypt, Arab Rep. to that in Equatorial Guinea?
Keep it short and to the point. 729.67. What is the ratio of the Emissions(kt) of 1961 in Egypt, Arab Rep. to that in Equatorial Guinea?
Your answer should be very brief. 776.67. What is the ratio of the Emissions(kt) of 1962 in Egypt, Arab Rep. to that in Equatorial Guinea?
Make the answer very short. 845.17. What is the ratio of the Emissions(kt) of 1963 in Egypt, Arab Rep. to that in Equatorial Guinea?
Provide a short and direct response. 839.71. What is the ratio of the Emissions(kt) in 1960 in Egypt, Arab Rep. to that in Ethiopia?
Make the answer very short. 45.6. What is the ratio of the Emissions(kt) in 1961 in Egypt, Arab Rep. to that in Ethiopia?
Make the answer very short. 50.11. What is the ratio of the Emissions(kt) of 1962 in Egypt, Arab Rep. to that in Ethiopia?
Your response must be concise. 46.95. What is the ratio of the Emissions(kt) of 1963 in Egypt, Arab Rep. to that in Ethiopia?
Provide a short and direct response. 51.11. What is the ratio of the Emissions(kt) in 1960 in Egypt, Arab Rep. to that in Faeroe Islands?
Your answer should be very brief. 273.62. What is the ratio of the Emissions(kt) of 1961 in Egypt, Arab Rep. to that in Faeroe Islands?
Offer a very short reply. 150.32. What is the ratio of the Emissions(kt) in 1962 in Egypt, Arab Rep. to that in Faeroe Islands?
Provide a short and direct response. 158.47. What is the ratio of the Emissions(kt) of 1963 in Egypt, Arab Rep. to that in Faeroe Islands?
Give a very brief answer. 172.88. What is the ratio of the Emissions(kt) in 1960 in El Salvador to that in Equatorial Guinea?
Offer a very short reply. 28.17. What is the ratio of the Emissions(kt) in 1961 in El Salvador to that in Equatorial Guinea?
Offer a terse response. 26.5. What is the ratio of the Emissions(kt) in 1962 in El Salvador to that in Equatorial Guinea?
Your answer should be compact. 29.5. What is the ratio of the Emissions(kt) of 1963 in El Salvador to that in Equatorial Guinea?
Your answer should be compact. 43.86. What is the ratio of the Emissions(kt) in 1960 in El Salvador to that in Ethiopia?
Your answer should be compact. 1.76. What is the ratio of the Emissions(kt) in 1961 in El Salvador to that in Ethiopia?
Your answer should be compact. 1.71. What is the ratio of the Emissions(kt) of 1962 in El Salvador to that in Ethiopia?
Offer a very short reply. 1.64. What is the ratio of the Emissions(kt) of 1963 in El Salvador to that in Ethiopia?
Your answer should be very brief. 2.67. What is the ratio of the Emissions(kt) of 1960 in El Salvador to that in Faeroe Islands?
Ensure brevity in your answer.  10.56. What is the ratio of the Emissions(kt) of 1961 in El Salvador to that in Faeroe Islands?
Your answer should be very brief. 5.13. What is the ratio of the Emissions(kt) in 1962 in El Salvador to that in Faeroe Islands?
Provide a succinct answer. 5.53. What is the ratio of the Emissions(kt) in 1963 in El Salvador to that in Faeroe Islands?
Make the answer very short. 9.03. What is the ratio of the Emissions(kt) of 1960 in Equatorial Guinea to that in Ethiopia?
Provide a short and direct response. 0.06. What is the ratio of the Emissions(kt) in 1961 in Equatorial Guinea to that in Ethiopia?
Keep it short and to the point. 0.06. What is the ratio of the Emissions(kt) of 1962 in Equatorial Guinea to that in Ethiopia?
Give a very brief answer. 0.06. What is the ratio of the Emissions(kt) in 1963 in Equatorial Guinea to that in Ethiopia?
Your answer should be very brief. 0.06. What is the ratio of the Emissions(kt) in 1960 in Equatorial Guinea to that in Faeroe Islands?
Give a very brief answer. 0.38. What is the ratio of the Emissions(kt) in 1961 in Equatorial Guinea to that in Faeroe Islands?
Ensure brevity in your answer.  0.19. What is the ratio of the Emissions(kt) in 1962 in Equatorial Guinea to that in Faeroe Islands?
Give a very brief answer. 0.19. What is the ratio of the Emissions(kt) of 1963 in Equatorial Guinea to that in Faeroe Islands?
Offer a very short reply. 0.21. What is the ratio of the Emissions(kt) in 1960 in Ethiopia to that in Faeroe Islands?
Provide a short and direct response. 6. What is the ratio of the Emissions(kt) in 1961 in Ethiopia to that in Faeroe Islands?
Keep it short and to the point. 3. What is the ratio of the Emissions(kt) of 1962 in Ethiopia to that in Faeroe Islands?
Provide a succinct answer. 3.38. What is the ratio of the Emissions(kt) of 1963 in Ethiopia to that in Faeroe Islands?
Offer a terse response. 3.38. What is the difference between the highest and the second highest Emissions(kt) in 1960?
Offer a very short reply. 1.43e+04. What is the difference between the highest and the second highest Emissions(kt) in 1961?
Your response must be concise. 1.54e+04. What is the difference between the highest and the second highest Emissions(kt) of 1962?
Provide a succinct answer. 1.70e+04. What is the difference between the highest and the second highest Emissions(kt) in 1963?
Offer a very short reply. 1.98e+04. What is the difference between the highest and the lowest Emissions(kt) of 1960?
Offer a very short reply. 1.60e+04. What is the difference between the highest and the lowest Emissions(kt) in 1961?
Provide a succinct answer. 1.71e+04. What is the difference between the highest and the lowest Emissions(kt) of 1962?
Offer a very short reply. 1.86e+04. What is the difference between the highest and the lowest Emissions(kt) of 1963?
Keep it short and to the point. 2.15e+04. 